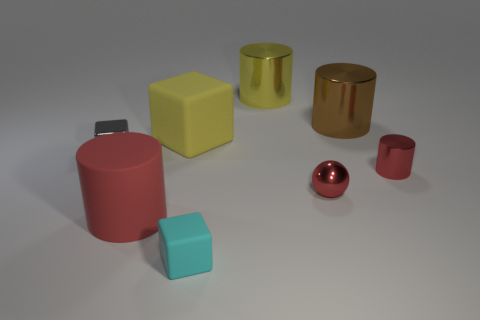Is the number of small objects in front of the tiny gray thing less than the number of small cylinders that are in front of the large yellow cylinder?
Your answer should be very brief. No. Is the ball the same color as the small metal block?
Your response must be concise. No. Are there fewer matte cylinders in front of the large yellow block than tiny brown metallic spheres?
Give a very brief answer. No. What material is the large object that is the same color as the metal ball?
Keep it short and to the point. Rubber. Is the big red object made of the same material as the cyan block?
Your answer should be compact. Yes. What number of small gray objects are the same material as the gray block?
Keep it short and to the point. 0. What color is the small cylinder that is the same material as the big brown object?
Your response must be concise. Red. There is a yellow metallic thing; what shape is it?
Make the answer very short. Cylinder. There is a cylinder in front of the red metal cylinder; what material is it?
Ensure brevity in your answer.  Rubber. Are there any tiny matte balls of the same color as the matte cylinder?
Your response must be concise. No. 